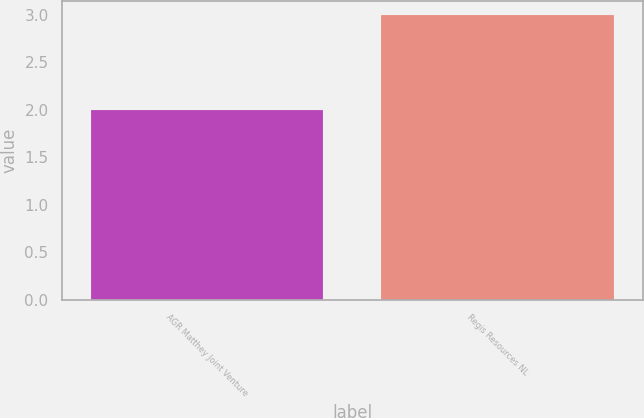Convert chart to OTSL. <chart><loc_0><loc_0><loc_500><loc_500><bar_chart><fcel>AGR Matthey Joint Venture<fcel>Regis Resources NL<nl><fcel>2<fcel>3<nl></chart> 